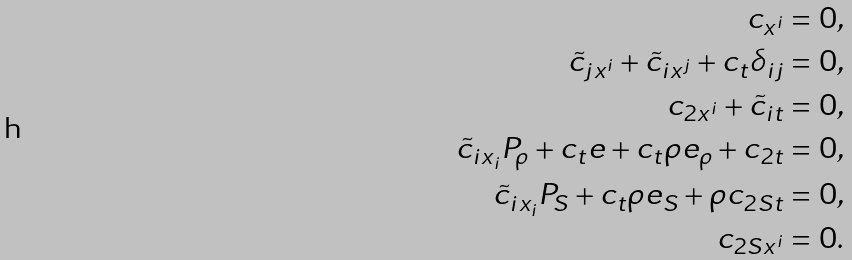<formula> <loc_0><loc_0><loc_500><loc_500>c _ { x ^ { i } } = 0 , \\ \tilde { c } _ { j x ^ { i } } + \tilde { c } _ { i x ^ { j } } + c _ { t } \delta _ { i j } = 0 , \\ c _ { 2 x ^ { i } } + \tilde { c } _ { i t } = 0 , \\ \tilde { c } _ { i x _ { i } } P _ { \rho } + c _ { t } e + c _ { t } \rho e _ { \rho } + c _ { 2 t } = 0 , \\ \tilde { c } _ { i x _ { i } } P _ { S } + c _ { t } \rho e _ { S } + \rho c _ { 2 S t } = 0 , \\ c _ { 2 S x ^ { i } } = 0 .</formula> 